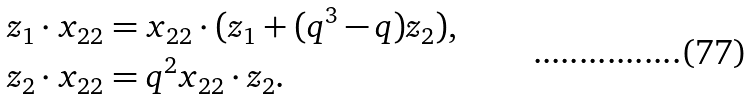Convert formula to latex. <formula><loc_0><loc_0><loc_500><loc_500>z _ { 1 } \cdot x _ { 2 2 } & = x _ { 2 2 } \cdot ( z _ { 1 } + ( q ^ { 3 } - q ) z _ { 2 } ) , \\ z _ { 2 } \cdot x _ { 2 2 } & = q ^ { 2 } x _ { 2 2 } \cdot z _ { 2 } .</formula> 